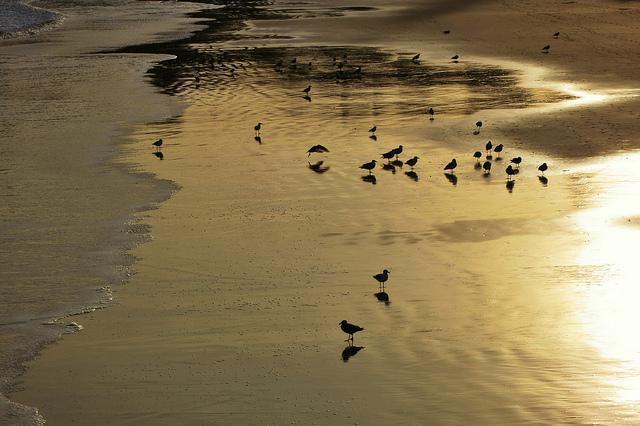How many red buses are there?
Give a very brief answer. 0. 